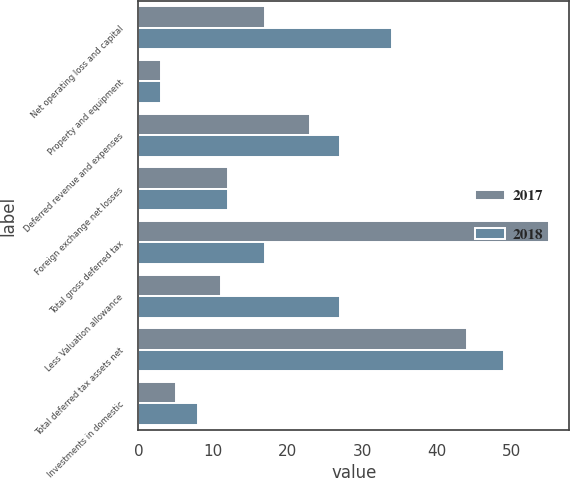Convert chart to OTSL. <chart><loc_0><loc_0><loc_500><loc_500><stacked_bar_chart><ecel><fcel>Net operating loss and capital<fcel>Property and equipment<fcel>Deferred revenue and expenses<fcel>Foreign exchange net losses<fcel>Total gross deferred tax<fcel>Less Valuation allowance<fcel>Total deferred tax assets net<fcel>Investments in domestic<nl><fcel>2017<fcel>17<fcel>3<fcel>23<fcel>12<fcel>55<fcel>11<fcel>44<fcel>5<nl><fcel>2018<fcel>34<fcel>3<fcel>27<fcel>12<fcel>17<fcel>27<fcel>49<fcel>8<nl></chart> 